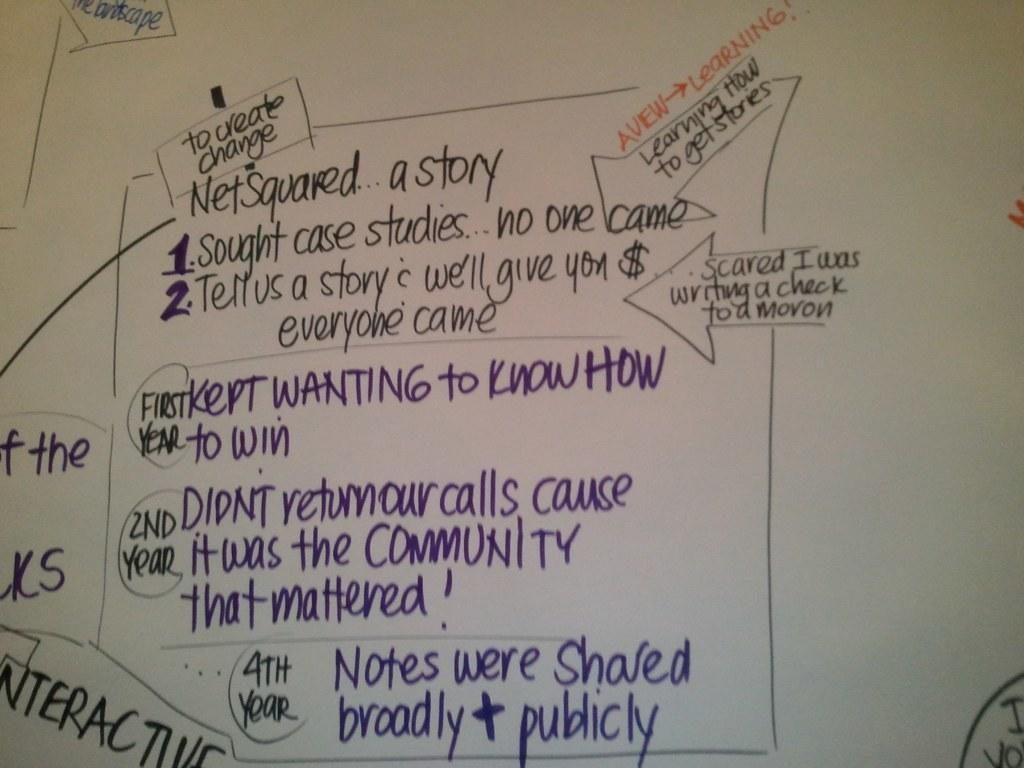<image>
Summarize the visual content of the image. A whiteboard with to create change written on it. 